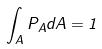Convert formula to latex. <formula><loc_0><loc_0><loc_500><loc_500>\int _ { A } P _ { A } d A = 1</formula> 